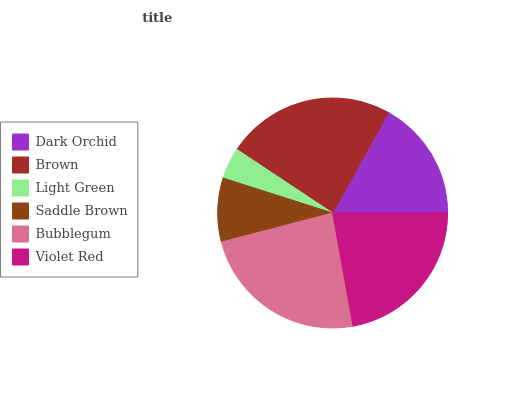Is Light Green the minimum?
Answer yes or no. Yes. Is Bubblegum the maximum?
Answer yes or no. Yes. Is Brown the minimum?
Answer yes or no. No. Is Brown the maximum?
Answer yes or no. No. Is Brown greater than Dark Orchid?
Answer yes or no. Yes. Is Dark Orchid less than Brown?
Answer yes or no. Yes. Is Dark Orchid greater than Brown?
Answer yes or no. No. Is Brown less than Dark Orchid?
Answer yes or no. No. Is Violet Red the high median?
Answer yes or no. Yes. Is Dark Orchid the low median?
Answer yes or no. Yes. Is Brown the high median?
Answer yes or no. No. Is Saddle Brown the low median?
Answer yes or no. No. 